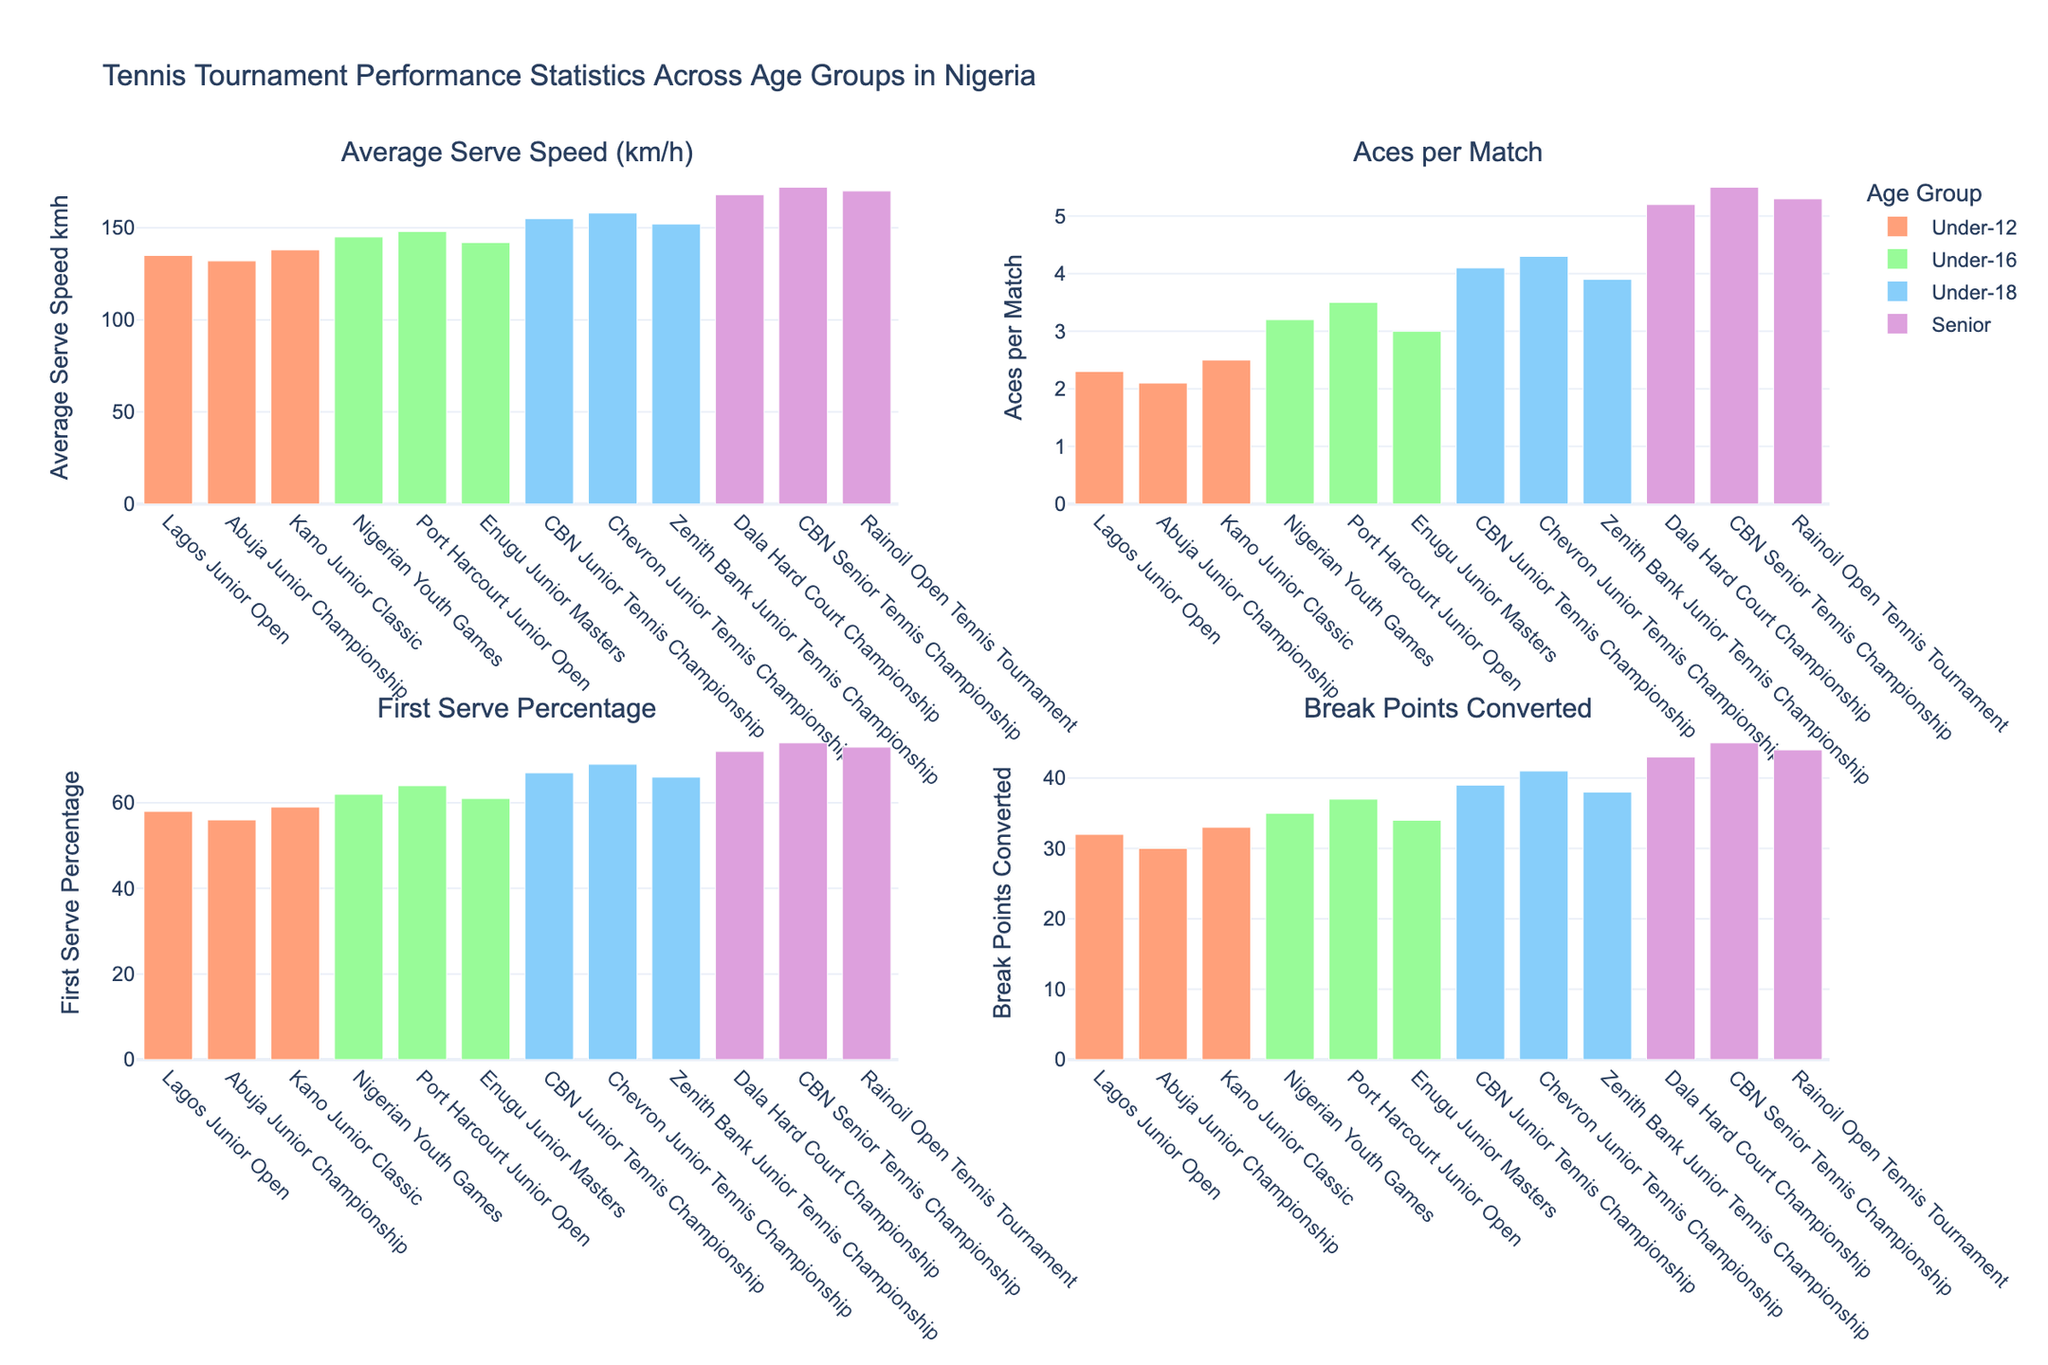How many subplots are there in the figure? The figure has a layout of 2 rows and 2 columns of subplots, which makes a total of 4 subplots.
Answer: 4 Which age group has the highest average serve speed in any tournament? By examining the Average Serve Speed (km/h) subplot, we can see that the Senior players in the CBN Senior Tennis Championship recorded the highest speed of 172 km/h.
Answer: Senior age group in CBN Senior Tennis Championship What is the total number of aces per match for Under-18 age group across all tournaments? In the Aces per Match subplot, the values for Under-18 age group are 4.1 (CBN Junior), 4.3 (Chevron Junior), and 3.9 (Zenith Bank Junior). Summing these values: 4.1 + 4.3 + 3.9 = 12.3
Answer: 12.3 How does the first serve percentage for Under-16 age group compare with Under-18 age group in the plot? By looking at the First Serve Percentage subplot: Under-16 has percentages of 62, 64, and 61, whereas Under-18 has percentages of 67, 69, and 66. The Under-18 group has higher first serve percentages compared to the Under-16 group.
Answer: Under-18 percentages are higher Which tournament has the least number of break points converted for the Under-12 age group? In the Break Points Converted subplot, for the Under-12 group, the values are 32 (Lagos Junior), 30 (Abuja Junior), and 33 (Kano Junior). The least number is 30 in Abuja Junior Championship.
Answer: Abuja Junior Championship Is the average serve speed consistently increasing with age group in the tournaments? By examining the Average Serve Speed subplot, we can see a general trend of increasing speed from Under-12s to Seniors, though there are slight variations within each age group.
Answer: Generally increasing What is the difference in the highest number of aces per match between the Under-16 and Senior age groups? In the Aces per Match subplot, the highest values are 3.5 for Under-16 (Port Harcourt Junior Open) and 5.5 for Seniors (CBN Senior Tennis Championship). The difference is 5.5 - 3.5 = 2.0
Answer: 2.0 Which age group has the highest break points converted rate? In the Break Points Converted subplot, the highest values for each age group are: Under-12 (33), Under-16 (37), Under-18 (41), and Seniors (45). The Senior age group has the highest value of 45 in the CBN Senior Tennis Championship.
Answer: Senior age group What is the average first serve percentage for the Under-16 age group across all their tournaments? The First Serve Percentage subplot shows values of 62, 64, and 61 for Under-16. Average is (62 + 64 + 61) / 3 = 187 / 3 = 62.33
Answer: 62.33 